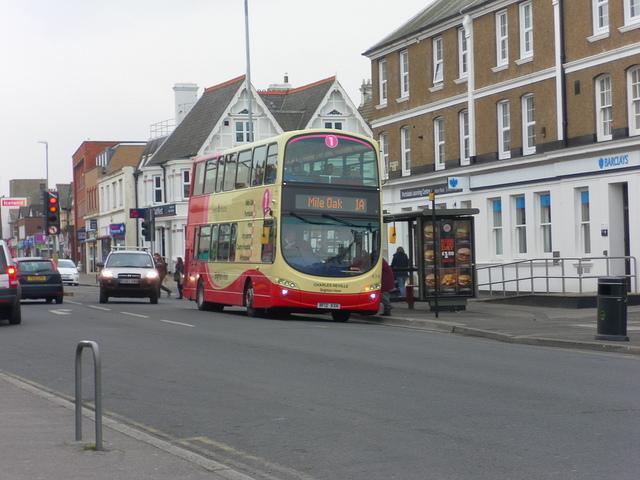How many seating levels are on the bus?
Give a very brief answer. 2. 